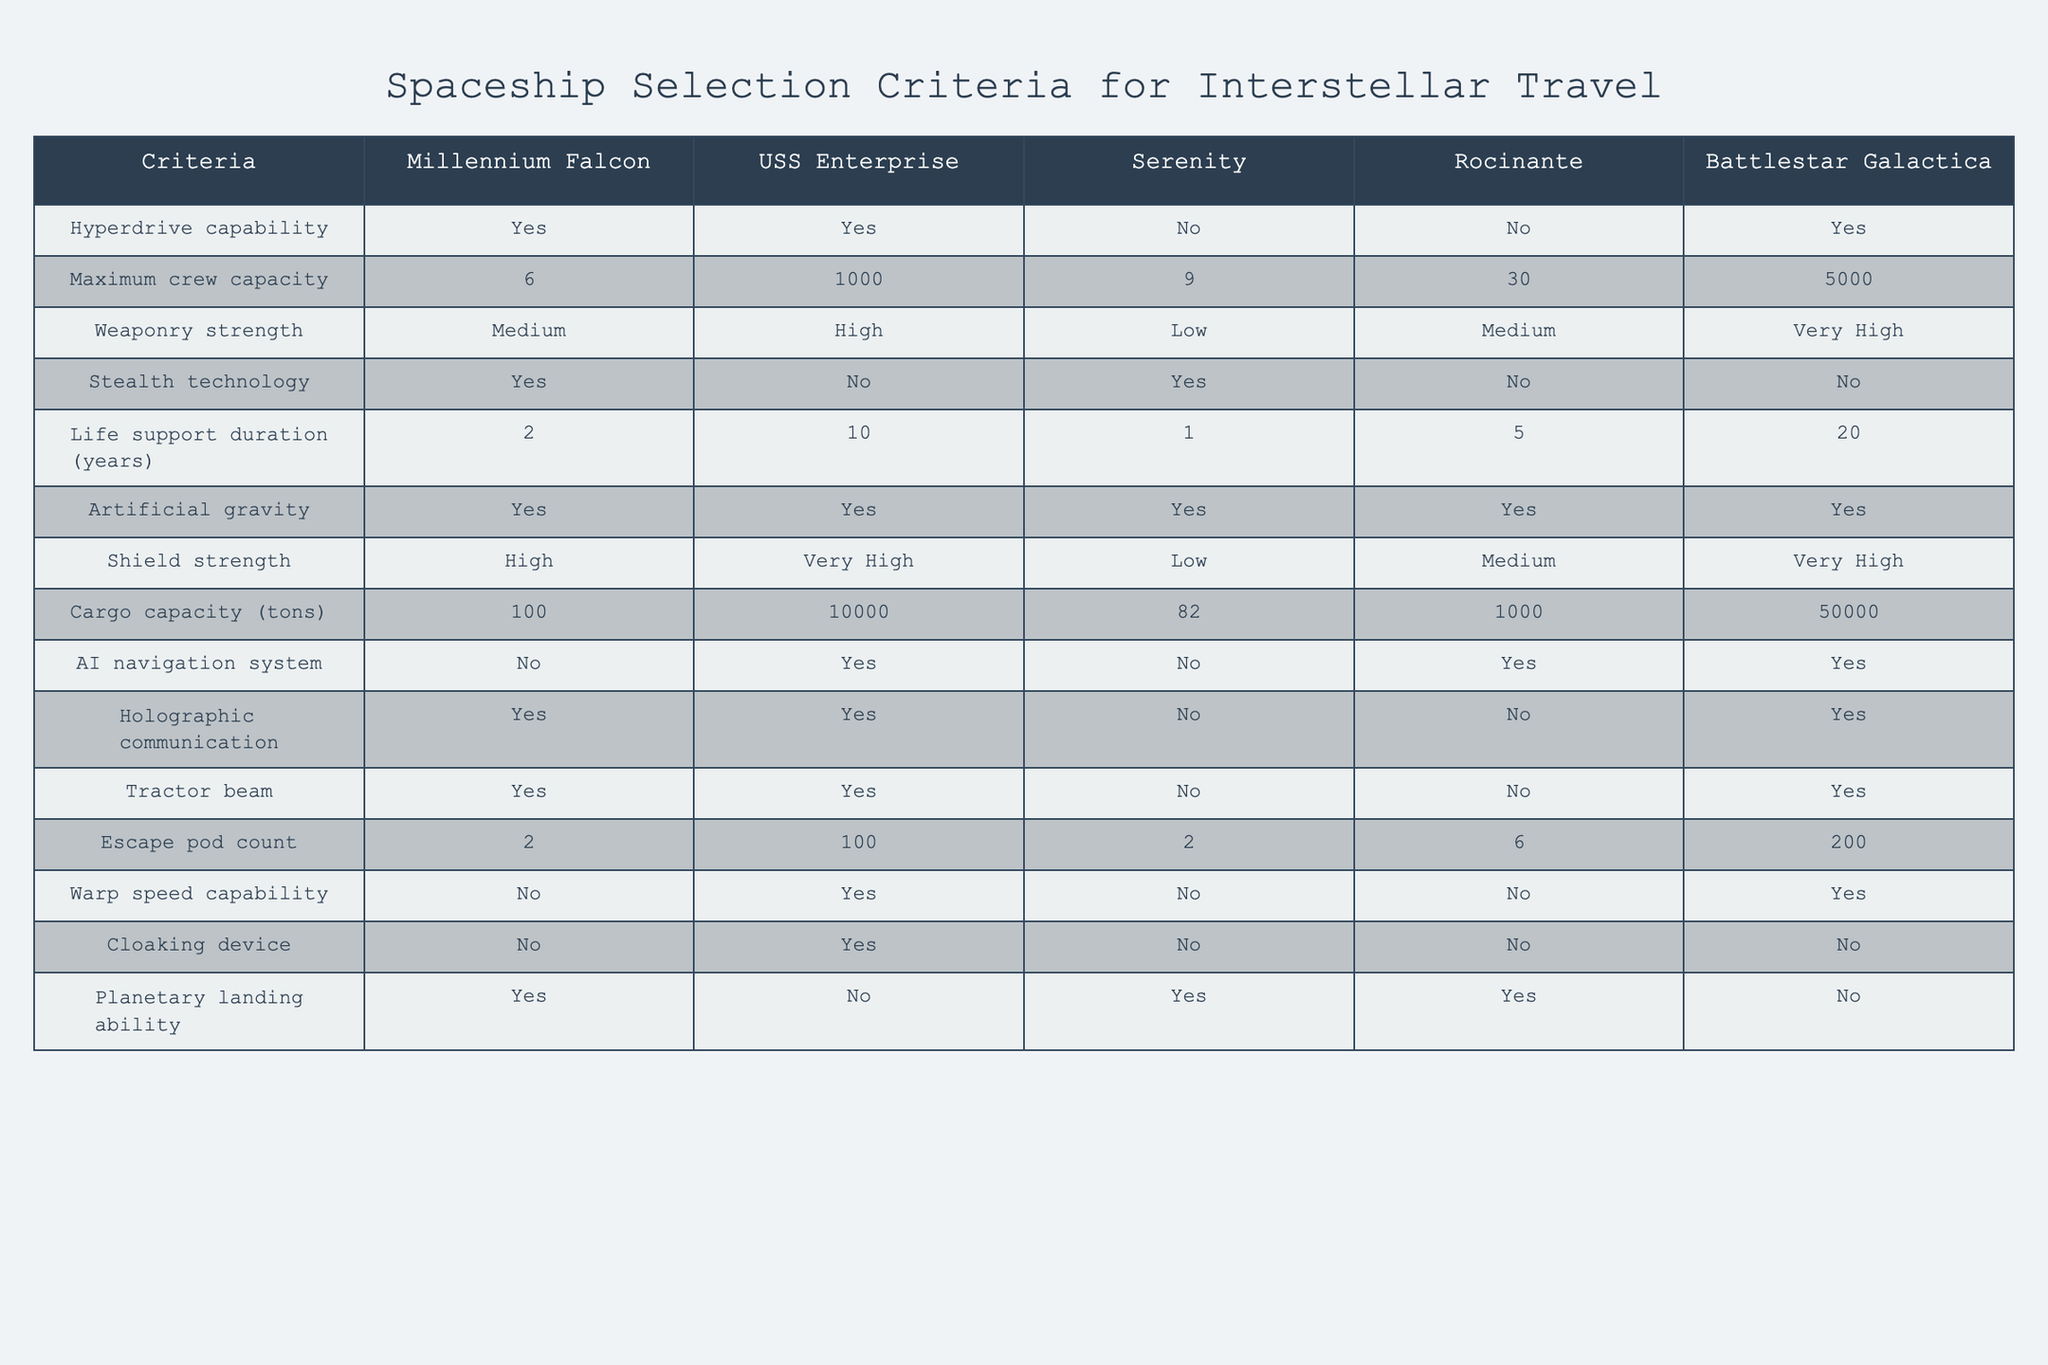What is the maximum crew capacity of the USS Enterprise? The table shows that the maximum crew capacity of the USS Enterprise is 1000.
Answer: 1000 Which spaceship has the highest weaponry strength? By comparing the weaponry strength listed in the table, Battlestar Galactica has the highest weaponry strength, rated as Very High.
Answer: Battlestar Galactica How many spaceships have AI navigation systems? The table indicates that a total of 3 spaceships have AI navigation systems: USS Enterprise, Rocinante, and Battlestar Galactica.
Answer: 3 What is the average life support duration of spaceships that can land on planets? The spaceships that can land on planets are the Millennium Falcon (2 years), Serenity (1 year), and Rocinante (5 years). Their total life support duration is 2 + 1 + 5 = 8 years. The average is 8/3 = approximately 2.67 years.
Answer: 2.67 years Does the Serenity possess a cloaking device? According to the table, the Serenity does not have a cloaking device, as indicated by "No" under that criterion.
Answer: No Which spaceship has the lowest cargo capacity, and what is that capacity? The table shows that Serenity has the lowest cargo capacity at 82 tons compared to the others, which are significantly higher.
Answer: 82 tons Can you list the ships that have high or very high shield strength? Looking at the shield strength column, the ships with high or very high shield strength are the Millennium Falcon (High) and Battlestar Galactica (Very High), and USS Enterprise (Very High).
Answer: Millennium Falcon, USS Enterprise, Battlestar Galactica What is the difference in maximum crew capacity between Battlestar Galactica and Serenity? Battlestar Galactica has a maximum crew capacity of 5000, whereas Serenity has a capacity of 9. The difference is 5000 - 9 = 4991.
Answer: 4991 Is there a spaceship that lacks both stealth technology and a cloaking device? The table identifies that Rocinante and Battlestar Galactica have "No" for stealth technology and cloaking device criteria, confirming that they lack both.
Answer: Yes, Rocinante and Battlestar Galactica 